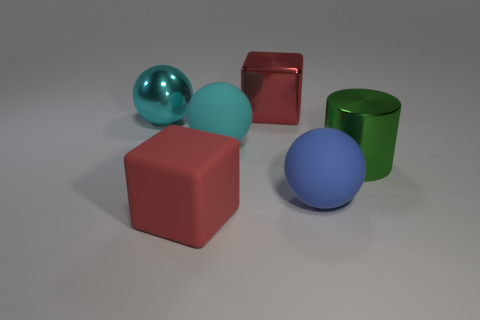Is the number of large cylinders that are behind the green cylinder greater than the number of brown cubes?
Ensure brevity in your answer.  No. There is a block that is behind the cyan metallic sphere; is its color the same as the shiny sphere?
Your response must be concise. No. Is there anything else of the same color as the metal block?
Your answer should be compact. Yes. There is a matte object that is behind the matte object that is to the right of the block behind the large blue ball; what color is it?
Keep it short and to the point. Cyan. Is the blue rubber ball the same size as the red metal object?
Provide a short and direct response. Yes. How many red rubber blocks have the same size as the cylinder?
Make the answer very short. 1. What shape is the large object that is the same color as the rubber block?
Your response must be concise. Cube. Do the red cube in front of the large green cylinder and the green cylinder on the right side of the large cyan rubber ball have the same material?
Ensure brevity in your answer.  No. Is there any other thing that has the same shape as the large green object?
Provide a short and direct response. No. The large shiny cylinder has what color?
Provide a short and direct response. Green. 